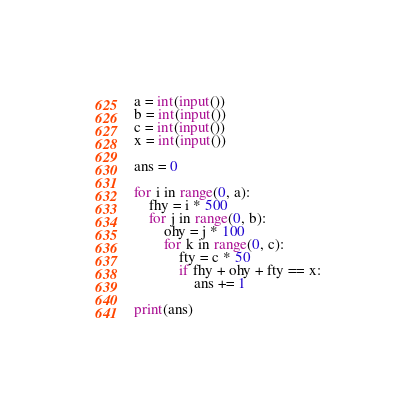<code> <loc_0><loc_0><loc_500><loc_500><_Python_>a = int(input())
b = int(input())
c = int(input())
x = int(input())

ans = 0

for i in range(0, a):
    fhy = i * 500
    for j in range(0, b):
        ohy = j * 100
        for k in range(0, c):
            fty = c * 50
            if fhy + ohy + fty == x:
                ans += 1

print(ans)</code> 